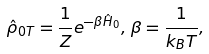<formula> <loc_0><loc_0><loc_500><loc_500>\hat { \rho } _ { 0 T } = \frac { 1 } { Z } e ^ { - \beta \hat { H } _ { 0 } } , \, \beta = \frac { 1 } { k _ { B } T } ,</formula> 